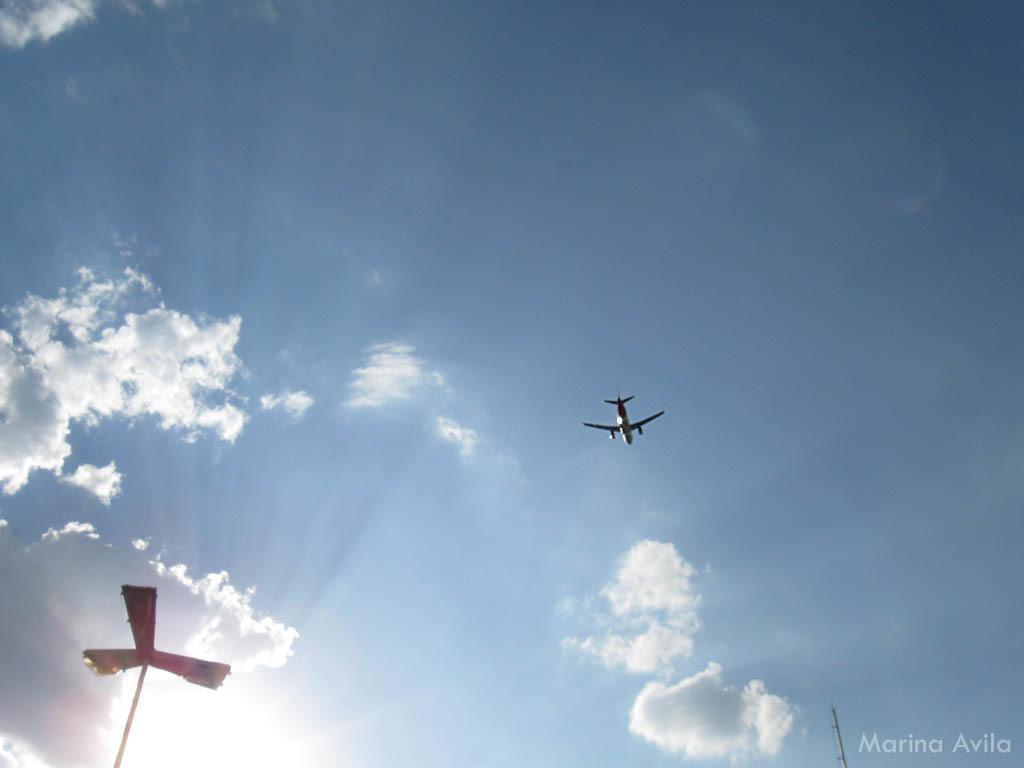How would you summarize this image in a sentence or two? On the left side of the image we can see a pole. In the center there is an aeroplane flying in the sky. 